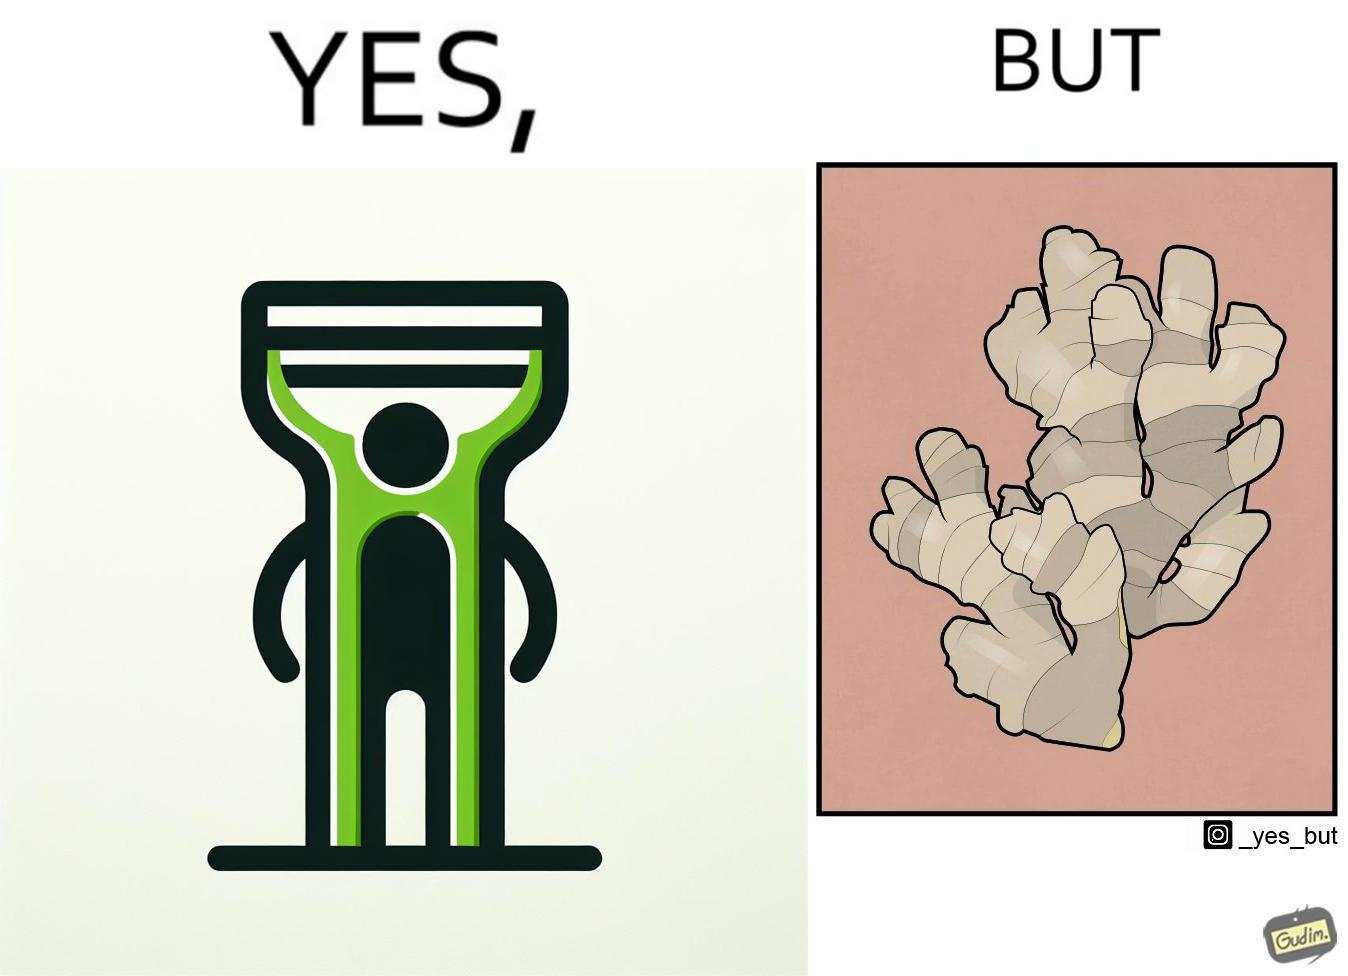Is this a satirical image? Yes, this image is satirical. 